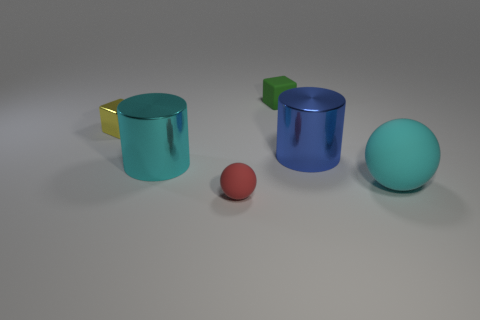Subtract all yellow cylinders. Subtract all gray balls. How many cylinders are left? 2 Add 3 big balls. How many objects exist? 9 Subtract all blocks. How many objects are left? 4 Add 1 tiny yellow shiny objects. How many tiny yellow shiny objects are left? 2 Add 1 cyan matte things. How many cyan matte things exist? 2 Subtract 0 purple cylinders. How many objects are left? 6 Subtract all big cyan shiny objects. Subtract all yellow metal cubes. How many objects are left? 4 